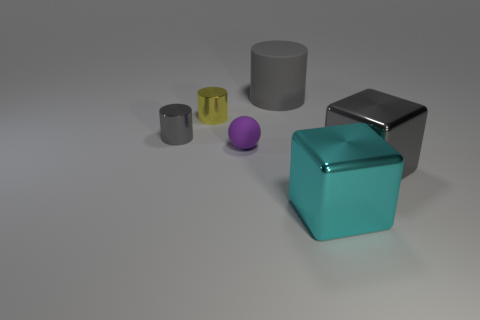Is there any other thing that has the same size as the purple sphere?
Provide a short and direct response. Yes. What material is the cylinder that is to the left of the big gray rubber cylinder and right of the small gray metallic cylinder?
Offer a very short reply. Metal. The cylinder left of the yellow cylinder is what color?
Give a very brief answer. Gray. There is a gray shiny object to the left of the tiny yellow cylinder; is its size the same as the matte object that is in front of the yellow shiny cylinder?
Your response must be concise. Yes. How many objects are either large cyan metal blocks or yellow matte cylinders?
Your response must be concise. 1. There is a cube that is in front of the large gray cube that is right of the cyan shiny object; what is its material?
Offer a very short reply. Metal. What number of other metal objects are the same shape as the big gray metal object?
Give a very brief answer. 1. Is there a metallic block of the same color as the big matte object?
Your answer should be very brief. Yes. How many things are either large things behind the tiny ball or gray objects on the left side of the small sphere?
Your answer should be compact. 2. There is a gray thing that is to the left of the large gray rubber thing; are there any gray metallic objects that are in front of it?
Your response must be concise. Yes. 